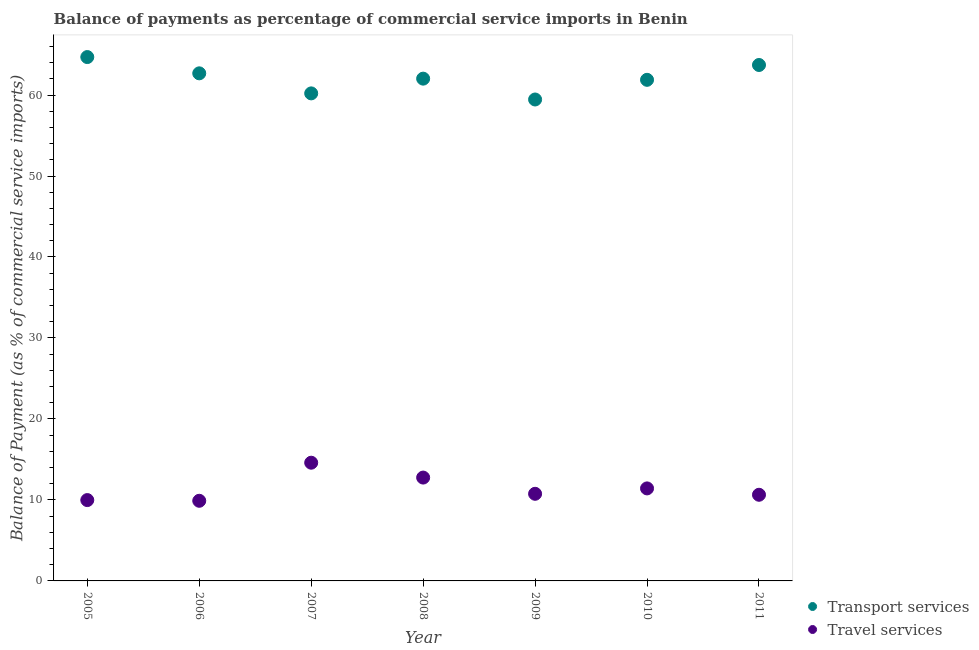How many different coloured dotlines are there?
Ensure brevity in your answer.  2. Is the number of dotlines equal to the number of legend labels?
Give a very brief answer. Yes. What is the balance of payments of transport services in 2005?
Your response must be concise. 64.69. Across all years, what is the maximum balance of payments of transport services?
Your answer should be compact. 64.69. Across all years, what is the minimum balance of payments of travel services?
Offer a terse response. 9.9. What is the total balance of payments of travel services in the graph?
Ensure brevity in your answer.  80.06. What is the difference between the balance of payments of travel services in 2008 and that in 2011?
Provide a short and direct response. 2.12. What is the difference between the balance of payments of transport services in 2011 and the balance of payments of travel services in 2005?
Offer a terse response. 53.73. What is the average balance of payments of travel services per year?
Offer a very short reply. 11.44. In the year 2011, what is the difference between the balance of payments of transport services and balance of payments of travel services?
Provide a short and direct response. 53.07. What is the ratio of the balance of payments of transport services in 2005 to that in 2006?
Your response must be concise. 1.03. Is the difference between the balance of payments of transport services in 2007 and 2010 greater than the difference between the balance of payments of travel services in 2007 and 2010?
Your answer should be compact. No. What is the difference between the highest and the second highest balance of payments of transport services?
Offer a terse response. 0.98. What is the difference between the highest and the lowest balance of payments of transport services?
Your response must be concise. 5.24. In how many years, is the balance of payments of travel services greater than the average balance of payments of travel services taken over all years?
Your answer should be compact. 2. Is the sum of the balance of payments of transport services in 2009 and 2010 greater than the maximum balance of payments of travel services across all years?
Offer a terse response. Yes. Does the balance of payments of transport services monotonically increase over the years?
Make the answer very short. No. What is the difference between two consecutive major ticks on the Y-axis?
Offer a very short reply. 10. Are the values on the major ticks of Y-axis written in scientific E-notation?
Your answer should be very brief. No. Does the graph contain grids?
Give a very brief answer. No. How many legend labels are there?
Ensure brevity in your answer.  2. What is the title of the graph?
Make the answer very short. Balance of payments as percentage of commercial service imports in Benin. What is the label or title of the Y-axis?
Your answer should be very brief. Balance of Payment (as % of commercial service imports). What is the Balance of Payment (as % of commercial service imports) of Transport services in 2005?
Keep it short and to the point. 64.69. What is the Balance of Payment (as % of commercial service imports) in Travel services in 2005?
Offer a very short reply. 9.98. What is the Balance of Payment (as % of commercial service imports) in Transport services in 2006?
Provide a succinct answer. 62.68. What is the Balance of Payment (as % of commercial service imports) of Travel services in 2006?
Provide a succinct answer. 9.9. What is the Balance of Payment (as % of commercial service imports) of Transport services in 2007?
Your response must be concise. 60.2. What is the Balance of Payment (as % of commercial service imports) of Travel services in 2007?
Your answer should be very brief. 14.6. What is the Balance of Payment (as % of commercial service imports) of Transport services in 2008?
Offer a terse response. 62.02. What is the Balance of Payment (as % of commercial service imports) in Travel services in 2008?
Your response must be concise. 12.76. What is the Balance of Payment (as % of commercial service imports) of Transport services in 2009?
Ensure brevity in your answer.  59.45. What is the Balance of Payment (as % of commercial service imports) in Travel services in 2009?
Keep it short and to the point. 10.76. What is the Balance of Payment (as % of commercial service imports) of Transport services in 2010?
Provide a succinct answer. 61.88. What is the Balance of Payment (as % of commercial service imports) in Travel services in 2010?
Ensure brevity in your answer.  11.42. What is the Balance of Payment (as % of commercial service imports) of Transport services in 2011?
Provide a short and direct response. 63.71. What is the Balance of Payment (as % of commercial service imports) in Travel services in 2011?
Make the answer very short. 10.64. Across all years, what is the maximum Balance of Payment (as % of commercial service imports) of Transport services?
Your answer should be compact. 64.69. Across all years, what is the maximum Balance of Payment (as % of commercial service imports) in Travel services?
Make the answer very short. 14.6. Across all years, what is the minimum Balance of Payment (as % of commercial service imports) in Transport services?
Give a very brief answer. 59.45. Across all years, what is the minimum Balance of Payment (as % of commercial service imports) of Travel services?
Give a very brief answer. 9.9. What is the total Balance of Payment (as % of commercial service imports) in Transport services in the graph?
Make the answer very short. 434.63. What is the total Balance of Payment (as % of commercial service imports) in Travel services in the graph?
Offer a terse response. 80.06. What is the difference between the Balance of Payment (as % of commercial service imports) of Transport services in 2005 and that in 2006?
Your answer should be very brief. 2.01. What is the difference between the Balance of Payment (as % of commercial service imports) of Travel services in 2005 and that in 2006?
Keep it short and to the point. 0.09. What is the difference between the Balance of Payment (as % of commercial service imports) of Transport services in 2005 and that in 2007?
Give a very brief answer. 4.49. What is the difference between the Balance of Payment (as % of commercial service imports) of Travel services in 2005 and that in 2007?
Provide a succinct answer. -4.61. What is the difference between the Balance of Payment (as % of commercial service imports) in Transport services in 2005 and that in 2008?
Offer a very short reply. 2.67. What is the difference between the Balance of Payment (as % of commercial service imports) of Travel services in 2005 and that in 2008?
Give a very brief answer. -2.78. What is the difference between the Balance of Payment (as % of commercial service imports) of Transport services in 2005 and that in 2009?
Provide a succinct answer. 5.24. What is the difference between the Balance of Payment (as % of commercial service imports) in Travel services in 2005 and that in 2009?
Offer a terse response. -0.78. What is the difference between the Balance of Payment (as % of commercial service imports) of Transport services in 2005 and that in 2010?
Provide a short and direct response. 2.81. What is the difference between the Balance of Payment (as % of commercial service imports) in Travel services in 2005 and that in 2010?
Provide a short and direct response. -1.44. What is the difference between the Balance of Payment (as % of commercial service imports) of Transport services in 2005 and that in 2011?
Keep it short and to the point. 0.98. What is the difference between the Balance of Payment (as % of commercial service imports) in Travel services in 2005 and that in 2011?
Your response must be concise. -0.66. What is the difference between the Balance of Payment (as % of commercial service imports) of Transport services in 2006 and that in 2007?
Keep it short and to the point. 2.48. What is the difference between the Balance of Payment (as % of commercial service imports) in Travel services in 2006 and that in 2007?
Offer a very short reply. -4.7. What is the difference between the Balance of Payment (as % of commercial service imports) of Transport services in 2006 and that in 2008?
Provide a short and direct response. 0.66. What is the difference between the Balance of Payment (as % of commercial service imports) of Travel services in 2006 and that in 2008?
Provide a succinct answer. -2.87. What is the difference between the Balance of Payment (as % of commercial service imports) of Transport services in 2006 and that in 2009?
Provide a succinct answer. 3.23. What is the difference between the Balance of Payment (as % of commercial service imports) of Travel services in 2006 and that in 2009?
Offer a very short reply. -0.86. What is the difference between the Balance of Payment (as % of commercial service imports) of Transport services in 2006 and that in 2010?
Your answer should be very brief. 0.8. What is the difference between the Balance of Payment (as % of commercial service imports) of Travel services in 2006 and that in 2010?
Ensure brevity in your answer.  -1.53. What is the difference between the Balance of Payment (as % of commercial service imports) in Transport services in 2006 and that in 2011?
Provide a succinct answer. -1.03. What is the difference between the Balance of Payment (as % of commercial service imports) of Travel services in 2006 and that in 2011?
Provide a succinct answer. -0.74. What is the difference between the Balance of Payment (as % of commercial service imports) in Transport services in 2007 and that in 2008?
Your answer should be very brief. -1.82. What is the difference between the Balance of Payment (as % of commercial service imports) in Travel services in 2007 and that in 2008?
Give a very brief answer. 1.84. What is the difference between the Balance of Payment (as % of commercial service imports) in Transport services in 2007 and that in 2009?
Your response must be concise. 0.75. What is the difference between the Balance of Payment (as % of commercial service imports) of Travel services in 2007 and that in 2009?
Your answer should be very brief. 3.84. What is the difference between the Balance of Payment (as % of commercial service imports) of Transport services in 2007 and that in 2010?
Your answer should be compact. -1.67. What is the difference between the Balance of Payment (as % of commercial service imports) in Travel services in 2007 and that in 2010?
Offer a very short reply. 3.17. What is the difference between the Balance of Payment (as % of commercial service imports) of Transport services in 2007 and that in 2011?
Provide a succinct answer. -3.51. What is the difference between the Balance of Payment (as % of commercial service imports) in Travel services in 2007 and that in 2011?
Offer a terse response. 3.96. What is the difference between the Balance of Payment (as % of commercial service imports) in Transport services in 2008 and that in 2009?
Provide a short and direct response. 2.57. What is the difference between the Balance of Payment (as % of commercial service imports) of Travel services in 2008 and that in 2009?
Give a very brief answer. 2. What is the difference between the Balance of Payment (as % of commercial service imports) of Transport services in 2008 and that in 2010?
Provide a short and direct response. 0.15. What is the difference between the Balance of Payment (as % of commercial service imports) in Travel services in 2008 and that in 2010?
Your answer should be compact. 1.34. What is the difference between the Balance of Payment (as % of commercial service imports) of Transport services in 2008 and that in 2011?
Keep it short and to the point. -1.69. What is the difference between the Balance of Payment (as % of commercial service imports) in Travel services in 2008 and that in 2011?
Offer a very short reply. 2.12. What is the difference between the Balance of Payment (as % of commercial service imports) in Transport services in 2009 and that in 2010?
Your answer should be very brief. -2.43. What is the difference between the Balance of Payment (as % of commercial service imports) of Travel services in 2009 and that in 2010?
Your answer should be very brief. -0.67. What is the difference between the Balance of Payment (as % of commercial service imports) in Transport services in 2009 and that in 2011?
Your answer should be very brief. -4.26. What is the difference between the Balance of Payment (as % of commercial service imports) of Travel services in 2009 and that in 2011?
Your answer should be very brief. 0.12. What is the difference between the Balance of Payment (as % of commercial service imports) of Transport services in 2010 and that in 2011?
Offer a terse response. -1.83. What is the difference between the Balance of Payment (as % of commercial service imports) of Travel services in 2010 and that in 2011?
Offer a very short reply. 0.79. What is the difference between the Balance of Payment (as % of commercial service imports) of Transport services in 2005 and the Balance of Payment (as % of commercial service imports) of Travel services in 2006?
Give a very brief answer. 54.79. What is the difference between the Balance of Payment (as % of commercial service imports) of Transport services in 2005 and the Balance of Payment (as % of commercial service imports) of Travel services in 2007?
Your response must be concise. 50.09. What is the difference between the Balance of Payment (as % of commercial service imports) of Transport services in 2005 and the Balance of Payment (as % of commercial service imports) of Travel services in 2008?
Offer a terse response. 51.93. What is the difference between the Balance of Payment (as % of commercial service imports) of Transport services in 2005 and the Balance of Payment (as % of commercial service imports) of Travel services in 2009?
Give a very brief answer. 53.93. What is the difference between the Balance of Payment (as % of commercial service imports) in Transport services in 2005 and the Balance of Payment (as % of commercial service imports) in Travel services in 2010?
Offer a terse response. 53.26. What is the difference between the Balance of Payment (as % of commercial service imports) of Transport services in 2005 and the Balance of Payment (as % of commercial service imports) of Travel services in 2011?
Your answer should be compact. 54.05. What is the difference between the Balance of Payment (as % of commercial service imports) in Transport services in 2006 and the Balance of Payment (as % of commercial service imports) in Travel services in 2007?
Offer a terse response. 48.08. What is the difference between the Balance of Payment (as % of commercial service imports) in Transport services in 2006 and the Balance of Payment (as % of commercial service imports) in Travel services in 2008?
Offer a very short reply. 49.92. What is the difference between the Balance of Payment (as % of commercial service imports) of Transport services in 2006 and the Balance of Payment (as % of commercial service imports) of Travel services in 2009?
Offer a very short reply. 51.92. What is the difference between the Balance of Payment (as % of commercial service imports) in Transport services in 2006 and the Balance of Payment (as % of commercial service imports) in Travel services in 2010?
Your answer should be compact. 51.26. What is the difference between the Balance of Payment (as % of commercial service imports) of Transport services in 2006 and the Balance of Payment (as % of commercial service imports) of Travel services in 2011?
Ensure brevity in your answer.  52.04. What is the difference between the Balance of Payment (as % of commercial service imports) in Transport services in 2007 and the Balance of Payment (as % of commercial service imports) in Travel services in 2008?
Provide a succinct answer. 47.44. What is the difference between the Balance of Payment (as % of commercial service imports) in Transport services in 2007 and the Balance of Payment (as % of commercial service imports) in Travel services in 2009?
Your answer should be compact. 49.45. What is the difference between the Balance of Payment (as % of commercial service imports) in Transport services in 2007 and the Balance of Payment (as % of commercial service imports) in Travel services in 2010?
Make the answer very short. 48.78. What is the difference between the Balance of Payment (as % of commercial service imports) in Transport services in 2007 and the Balance of Payment (as % of commercial service imports) in Travel services in 2011?
Give a very brief answer. 49.57. What is the difference between the Balance of Payment (as % of commercial service imports) of Transport services in 2008 and the Balance of Payment (as % of commercial service imports) of Travel services in 2009?
Offer a terse response. 51.27. What is the difference between the Balance of Payment (as % of commercial service imports) of Transport services in 2008 and the Balance of Payment (as % of commercial service imports) of Travel services in 2010?
Provide a short and direct response. 50.6. What is the difference between the Balance of Payment (as % of commercial service imports) of Transport services in 2008 and the Balance of Payment (as % of commercial service imports) of Travel services in 2011?
Your answer should be compact. 51.38. What is the difference between the Balance of Payment (as % of commercial service imports) of Transport services in 2009 and the Balance of Payment (as % of commercial service imports) of Travel services in 2010?
Your response must be concise. 48.03. What is the difference between the Balance of Payment (as % of commercial service imports) of Transport services in 2009 and the Balance of Payment (as % of commercial service imports) of Travel services in 2011?
Your answer should be very brief. 48.81. What is the difference between the Balance of Payment (as % of commercial service imports) in Transport services in 2010 and the Balance of Payment (as % of commercial service imports) in Travel services in 2011?
Ensure brevity in your answer.  51.24. What is the average Balance of Payment (as % of commercial service imports) in Transport services per year?
Provide a succinct answer. 62.09. What is the average Balance of Payment (as % of commercial service imports) in Travel services per year?
Your response must be concise. 11.44. In the year 2005, what is the difference between the Balance of Payment (as % of commercial service imports) of Transport services and Balance of Payment (as % of commercial service imports) of Travel services?
Offer a very short reply. 54.71. In the year 2006, what is the difference between the Balance of Payment (as % of commercial service imports) in Transport services and Balance of Payment (as % of commercial service imports) in Travel services?
Provide a short and direct response. 52.78. In the year 2007, what is the difference between the Balance of Payment (as % of commercial service imports) of Transport services and Balance of Payment (as % of commercial service imports) of Travel services?
Provide a short and direct response. 45.61. In the year 2008, what is the difference between the Balance of Payment (as % of commercial service imports) of Transport services and Balance of Payment (as % of commercial service imports) of Travel services?
Provide a succinct answer. 49.26. In the year 2009, what is the difference between the Balance of Payment (as % of commercial service imports) of Transport services and Balance of Payment (as % of commercial service imports) of Travel services?
Ensure brevity in your answer.  48.69. In the year 2010, what is the difference between the Balance of Payment (as % of commercial service imports) of Transport services and Balance of Payment (as % of commercial service imports) of Travel services?
Offer a terse response. 50.45. In the year 2011, what is the difference between the Balance of Payment (as % of commercial service imports) in Transport services and Balance of Payment (as % of commercial service imports) in Travel services?
Make the answer very short. 53.07. What is the ratio of the Balance of Payment (as % of commercial service imports) of Transport services in 2005 to that in 2006?
Your answer should be very brief. 1.03. What is the ratio of the Balance of Payment (as % of commercial service imports) in Travel services in 2005 to that in 2006?
Make the answer very short. 1.01. What is the ratio of the Balance of Payment (as % of commercial service imports) of Transport services in 2005 to that in 2007?
Your response must be concise. 1.07. What is the ratio of the Balance of Payment (as % of commercial service imports) in Travel services in 2005 to that in 2007?
Your response must be concise. 0.68. What is the ratio of the Balance of Payment (as % of commercial service imports) of Transport services in 2005 to that in 2008?
Your response must be concise. 1.04. What is the ratio of the Balance of Payment (as % of commercial service imports) in Travel services in 2005 to that in 2008?
Make the answer very short. 0.78. What is the ratio of the Balance of Payment (as % of commercial service imports) in Transport services in 2005 to that in 2009?
Provide a short and direct response. 1.09. What is the ratio of the Balance of Payment (as % of commercial service imports) of Travel services in 2005 to that in 2009?
Your answer should be compact. 0.93. What is the ratio of the Balance of Payment (as % of commercial service imports) of Transport services in 2005 to that in 2010?
Provide a short and direct response. 1.05. What is the ratio of the Balance of Payment (as % of commercial service imports) of Travel services in 2005 to that in 2010?
Your response must be concise. 0.87. What is the ratio of the Balance of Payment (as % of commercial service imports) of Transport services in 2005 to that in 2011?
Your answer should be very brief. 1.02. What is the ratio of the Balance of Payment (as % of commercial service imports) of Travel services in 2005 to that in 2011?
Ensure brevity in your answer.  0.94. What is the ratio of the Balance of Payment (as % of commercial service imports) of Transport services in 2006 to that in 2007?
Make the answer very short. 1.04. What is the ratio of the Balance of Payment (as % of commercial service imports) in Travel services in 2006 to that in 2007?
Provide a short and direct response. 0.68. What is the ratio of the Balance of Payment (as % of commercial service imports) in Transport services in 2006 to that in 2008?
Keep it short and to the point. 1.01. What is the ratio of the Balance of Payment (as % of commercial service imports) of Travel services in 2006 to that in 2008?
Your answer should be very brief. 0.78. What is the ratio of the Balance of Payment (as % of commercial service imports) of Transport services in 2006 to that in 2009?
Offer a very short reply. 1.05. What is the ratio of the Balance of Payment (as % of commercial service imports) of Travel services in 2006 to that in 2009?
Provide a short and direct response. 0.92. What is the ratio of the Balance of Payment (as % of commercial service imports) in Transport services in 2006 to that in 2010?
Provide a short and direct response. 1.01. What is the ratio of the Balance of Payment (as % of commercial service imports) of Travel services in 2006 to that in 2010?
Ensure brevity in your answer.  0.87. What is the ratio of the Balance of Payment (as % of commercial service imports) in Transport services in 2006 to that in 2011?
Your response must be concise. 0.98. What is the ratio of the Balance of Payment (as % of commercial service imports) in Travel services in 2006 to that in 2011?
Provide a succinct answer. 0.93. What is the ratio of the Balance of Payment (as % of commercial service imports) in Transport services in 2007 to that in 2008?
Offer a very short reply. 0.97. What is the ratio of the Balance of Payment (as % of commercial service imports) of Travel services in 2007 to that in 2008?
Ensure brevity in your answer.  1.14. What is the ratio of the Balance of Payment (as % of commercial service imports) of Transport services in 2007 to that in 2009?
Your answer should be compact. 1.01. What is the ratio of the Balance of Payment (as % of commercial service imports) in Travel services in 2007 to that in 2009?
Provide a short and direct response. 1.36. What is the ratio of the Balance of Payment (as % of commercial service imports) of Transport services in 2007 to that in 2010?
Your answer should be very brief. 0.97. What is the ratio of the Balance of Payment (as % of commercial service imports) in Travel services in 2007 to that in 2010?
Give a very brief answer. 1.28. What is the ratio of the Balance of Payment (as % of commercial service imports) in Transport services in 2007 to that in 2011?
Offer a very short reply. 0.94. What is the ratio of the Balance of Payment (as % of commercial service imports) in Travel services in 2007 to that in 2011?
Your response must be concise. 1.37. What is the ratio of the Balance of Payment (as % of commercial service imports) in Transport services in 2008 to that in 2009?
Your answer should be compact. 1.04. What is the ratio of the Balance of Payment (as % of commercial service imports) of Travel services in 2008 to that in 2009?
Ensure brevity in your answer.  1.19. What is the ratio of the Balance of Payment (as % of commercial service imports) of Transport services in 2008 to that in 2010?
Ensure brevity in your answer.  1. What is the ratio of the Balance of Payment (as % of commercial service imports) of Travel services in 2008 to that in 2010?
Provide a short and direct response. 1.12. What is the ratio of the Balance of Payment (as % of commercial service imports) in Transport services in 2008 to that in 2011?
Your answer should be compact. 0.97. What is the ratio of the Balance of Payment (as % of commercial service imports) in Travel services in 2008 to that in 2011?
Your answer should be very brief. 1.2. What is the ratio of the Balance of Payment (as % of commercial service imports) in Transport services in 2009 to that in 2010?
Your answer should be very brief. 0.96. What is the ratio of the Balance of Payment (as % of commercial service imports) in Travel services in 2009 to that in 2010?
Your answer should be compact. 0.94. What is the ratio of the Balance of Payment (as % of commercial service imports) in Transport services in 2009 to that in 2011?
Offer a terse response. 0.93. What is the ratio of the Balance of Payment (as % of commercial service imports) in Travel services in 2009 to that in 2011?
Your answer should be compact. 1.01. What is the ratio of the Balance of Payment (as % of commercial service imports) of Transport services in 2010 to that in 2011?
Your answer should be very brief. 0.97. What is the ratio of the Balance of Payment (as % of commercial service imports) in Travel services in 2010 to that in 2011?
Give a very brief answer. 1.07. What is the difference between the highest and the second highest Balance of Payment (as % of commercial service imports) of Travel services?
Your answer should be compact. 1.84. What is the difference between the highest and the lowest Balance of Payment (as % of commercial service imports) of Transport services?
Make the answer very short. 5.24. What is the difference between the highest and the lowest Balance of Payment (as % of commercial service imports) in Travel services?
Offer a very short reply. 4.7. 